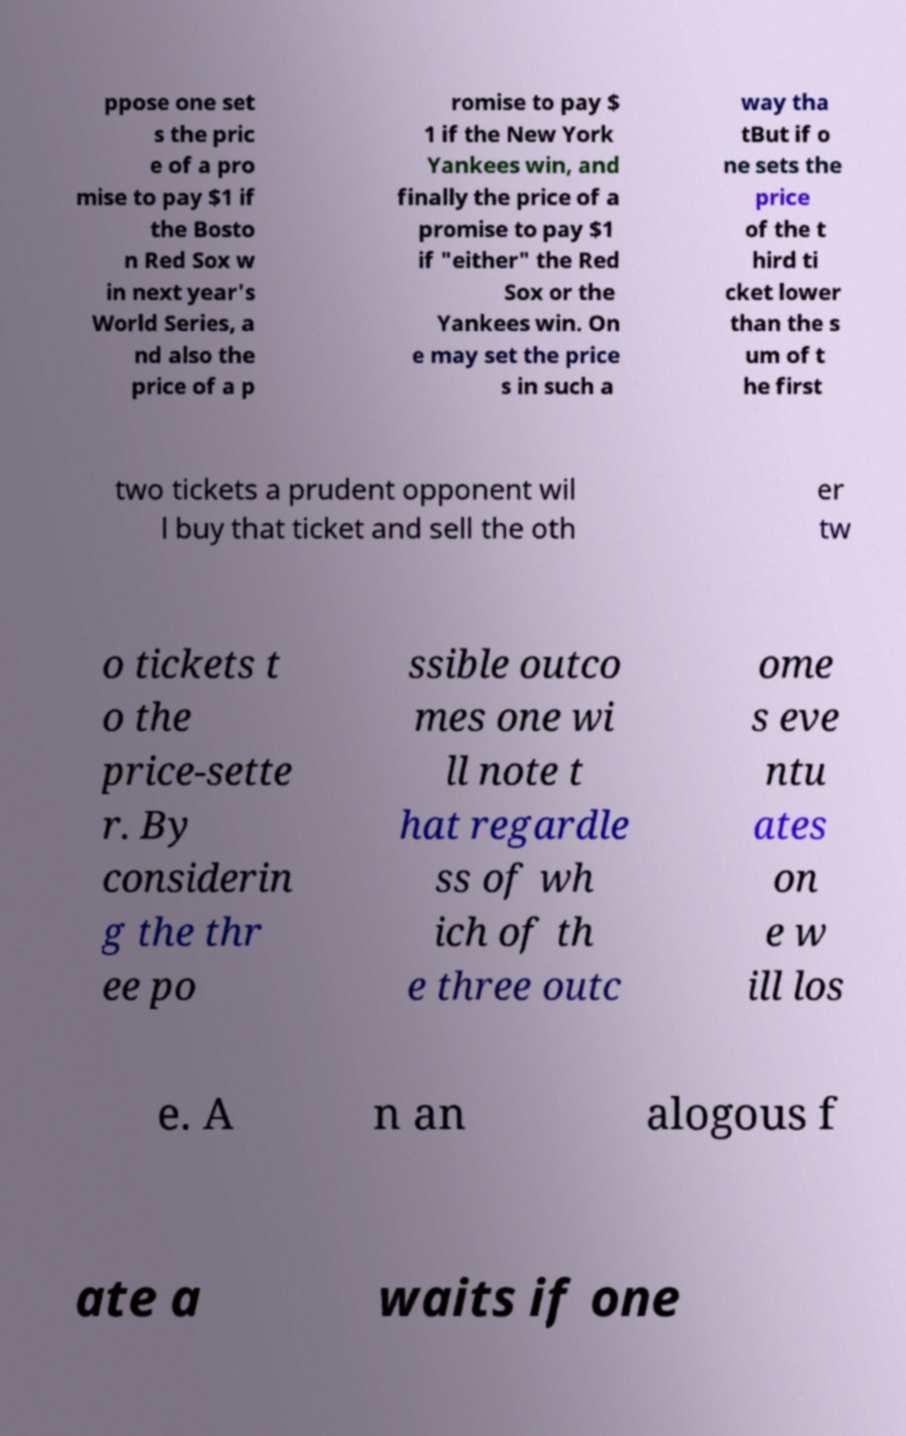Could you assist in decoding the text presented in this image and type it out clearly? ppose one set s the pric e of a pro mise to pay $1 if the Bosto n Red Sox w in next year's World Series, a nd also the price of a p romise to pay $ 1 if the New York Yankees win, and finally the price of a promise to pay $1 if "either" the Red Sox or the Yankees win. On e may set the price s in such a way tha tBut if o ne sets the price of the t hird ti cket lower than the s um of t he first two tickets a prudent opponent wil l buy that ticket and sell the oth er tw o tickets t o the price-sette r. By considerin g the thr ee po ssible outco mes one wi ll note t hat regardle ss of wh ich of th e three outc ome s eve ntu ates on e w ill los e. A n an alogous f ate a waits if one 